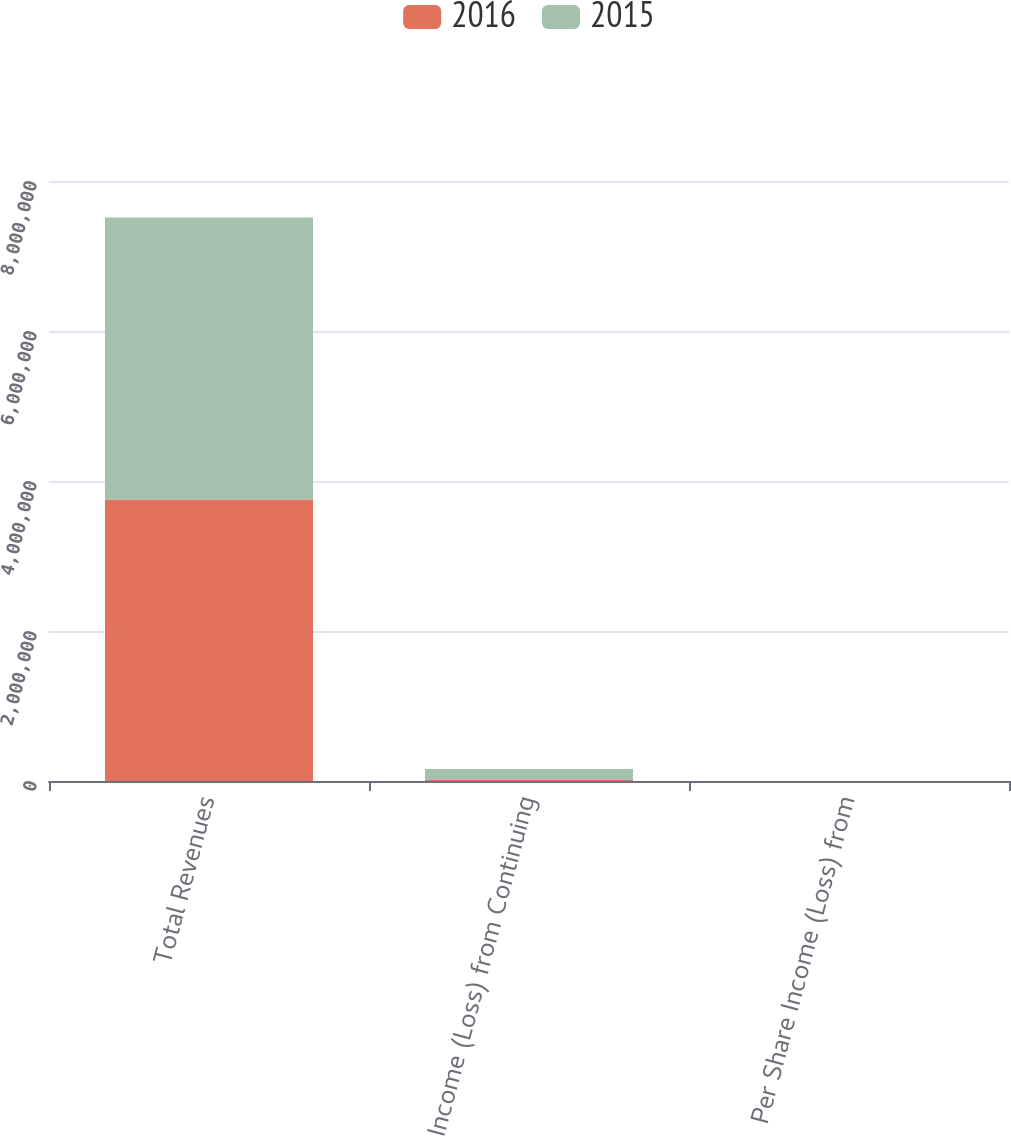Convert chart to OTSL. <chart><loc_0><loc_0><loc_500><loc_500><stacked_bar_chart><ecel><fcel>Total Revenues<fcel>Income (Loss) from Continuing<fcel>Per Share Income (Loss) from<nl><fcel>2016<fcel>3.7527e+06<fcel>12416<fcel>0.05<nl><fcel>2015<fcel>3.76223e+06<fcel>148422<fcel>0.56<nl></chart> 